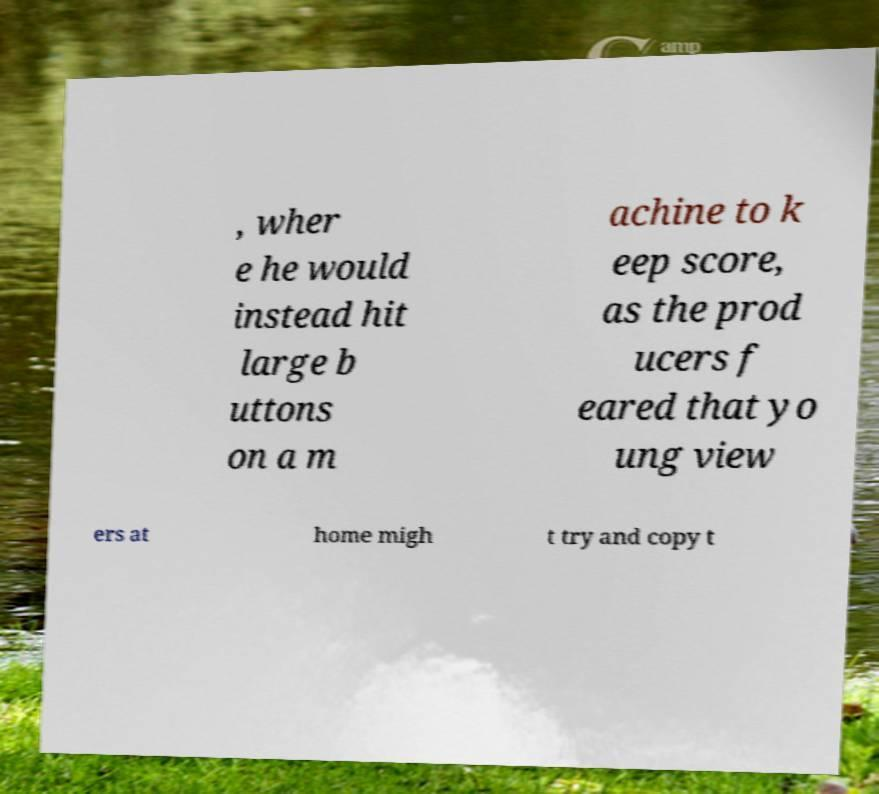I need the written content from this picture converted into text. Can you do that? , wher e he would instead hit large b uttons on a m achine to k eep score, as the prod ucers f eared that yo ung view ers at home migh t try and copy t 